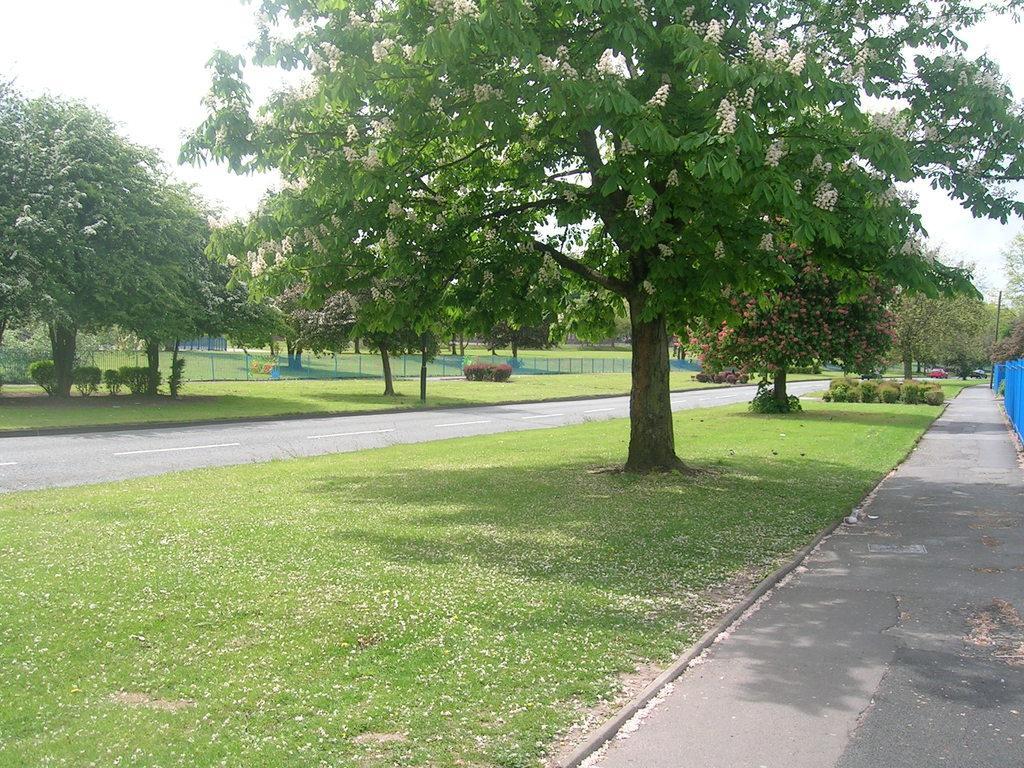Could you give a brief overview of what you see in this image? In this image we can see a group of trees with flowers. We can also see a fence, a vehicle, the road, grass, plants, poles and the sky which looks cloudy. 